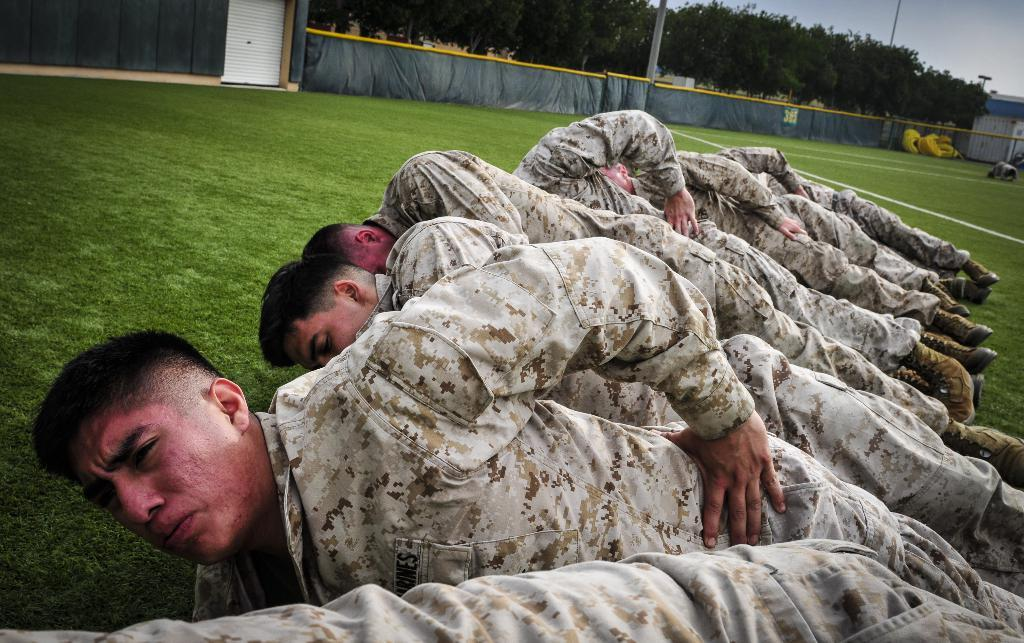What type of clothing are the people wearing in the image? The people are wearing military uniforms in the image. What are the people doing in the image? The people are lying on the grass. What can be seen in the background of the image? There are trees in the background of the image. What other objects are present in the image? There are poles in the image. What is visible above the people and trees in the image? The sky is visible in the image. What is the name of the machine that the people are operating in the image? There is no machine present in the image; the people are lying on the grass. Can you hear thunder in the image? The image is silent, and there is no indication of thunder or any sound. 